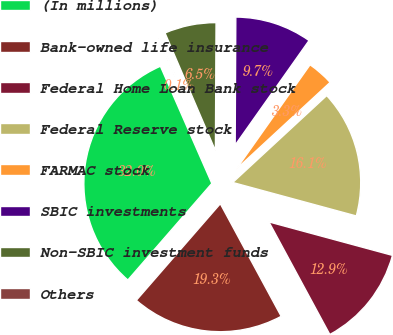Convert chart to OTSL. <chart><loc_0><loc_0><loc_500><loc_500><pie_chart><fcel>(In millions)<fcel>Bank-owned life insurance<fcel>Federal Home Loan Bank stock<fcel>Federal Reserve stock<fcel>FARMAC stock<fcel>SBIC investments<fcel>Non-SBIC investment funds<fcel>Others<nl><fcel>32.03%<fcel>19.28%<fcel>12.9%<fcel>16.09%<fcel>3.33%<fcel>9.71%<fcel>6.52%<fcel>0.14%<nl></chart> 